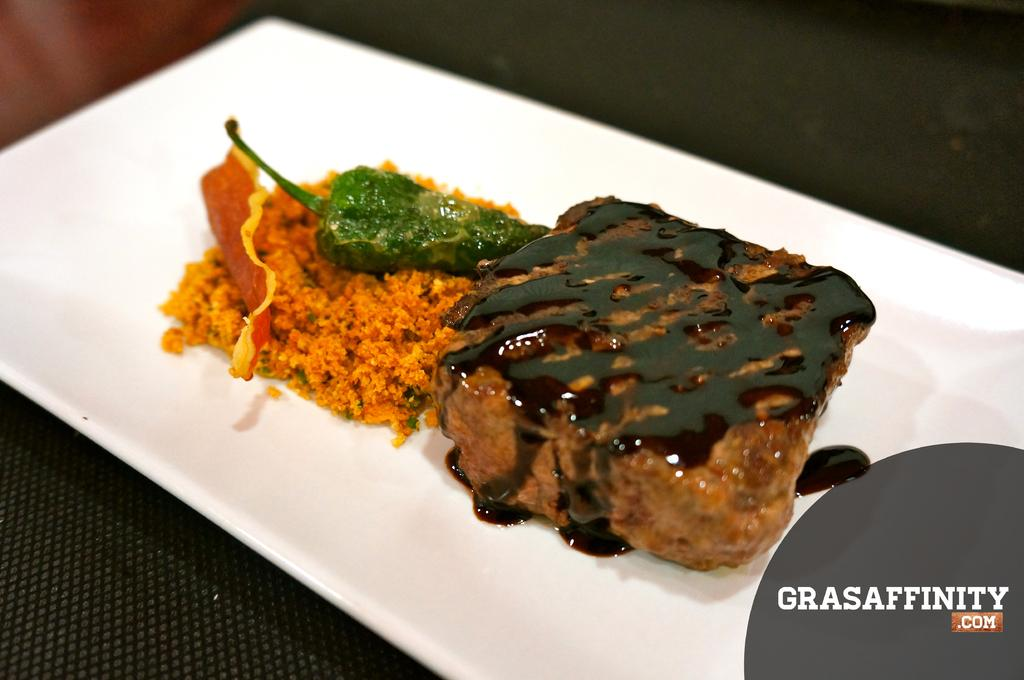What is on the plate that is visible in the image? There is a plate with food in the image. Where is the plate located in the image? The plate is placed on a table in the image. What can be found in the bottom right corner of the image? There is text in the bottom right corner of the image. How many hills can be seen in the image? There are no hills visible in the image. What is the credit value of the food on the plate? There is no information about the credit value of the food in the image. 